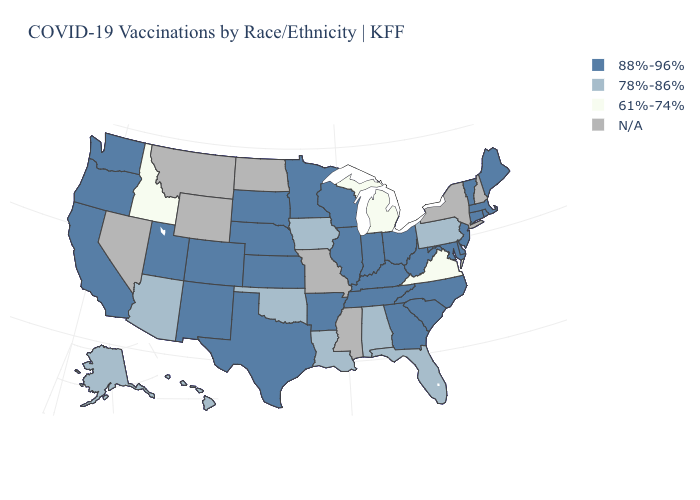Which states have the lowest value in the West?
Concise answer only. Idaho. Does the map have missing data?
Write a very short answer. Yes. Does Michigan have the lowest value in the MidWest?
Give a very brief answer. Yes. Which states have the lowest value in the South?
Write a very short answer. Virginia. Name the states that have a value in the range 88%-96%?
Write a very short answer. Arkansas, California, Colorado, Connecticut, Delaware, Georgia, Illinois, Indiana, Kansas, Kentucky, Maine, Maryland, Massachusetts, Minnesota, Nebraska, New Jersey, New Mexico, North Carolina, Ohio, Oregon, Rhode Island, South Carolina, South Dakota, Tennessee, Texas, Utah, Vermont, Washington, West Virginia, Wisconsin. How many symbols are there in the legend?
Keep it brief. 4. Among the states that border New Jersey , which have the lowest value?
Short answer required. Pennsylvania. What is the value of Massachusetts?
Quick response, please. 88%-96%. What is the highest value in states that border Vermont?
Quick response, please. 88%-96%. What is the highest value in the USA?
Concise answer only. 88%-96%. What is the highest value in the USA?
Be succinct. 88%-96%. What is the value of Kansas?
Be succinct. 88%-96%. 